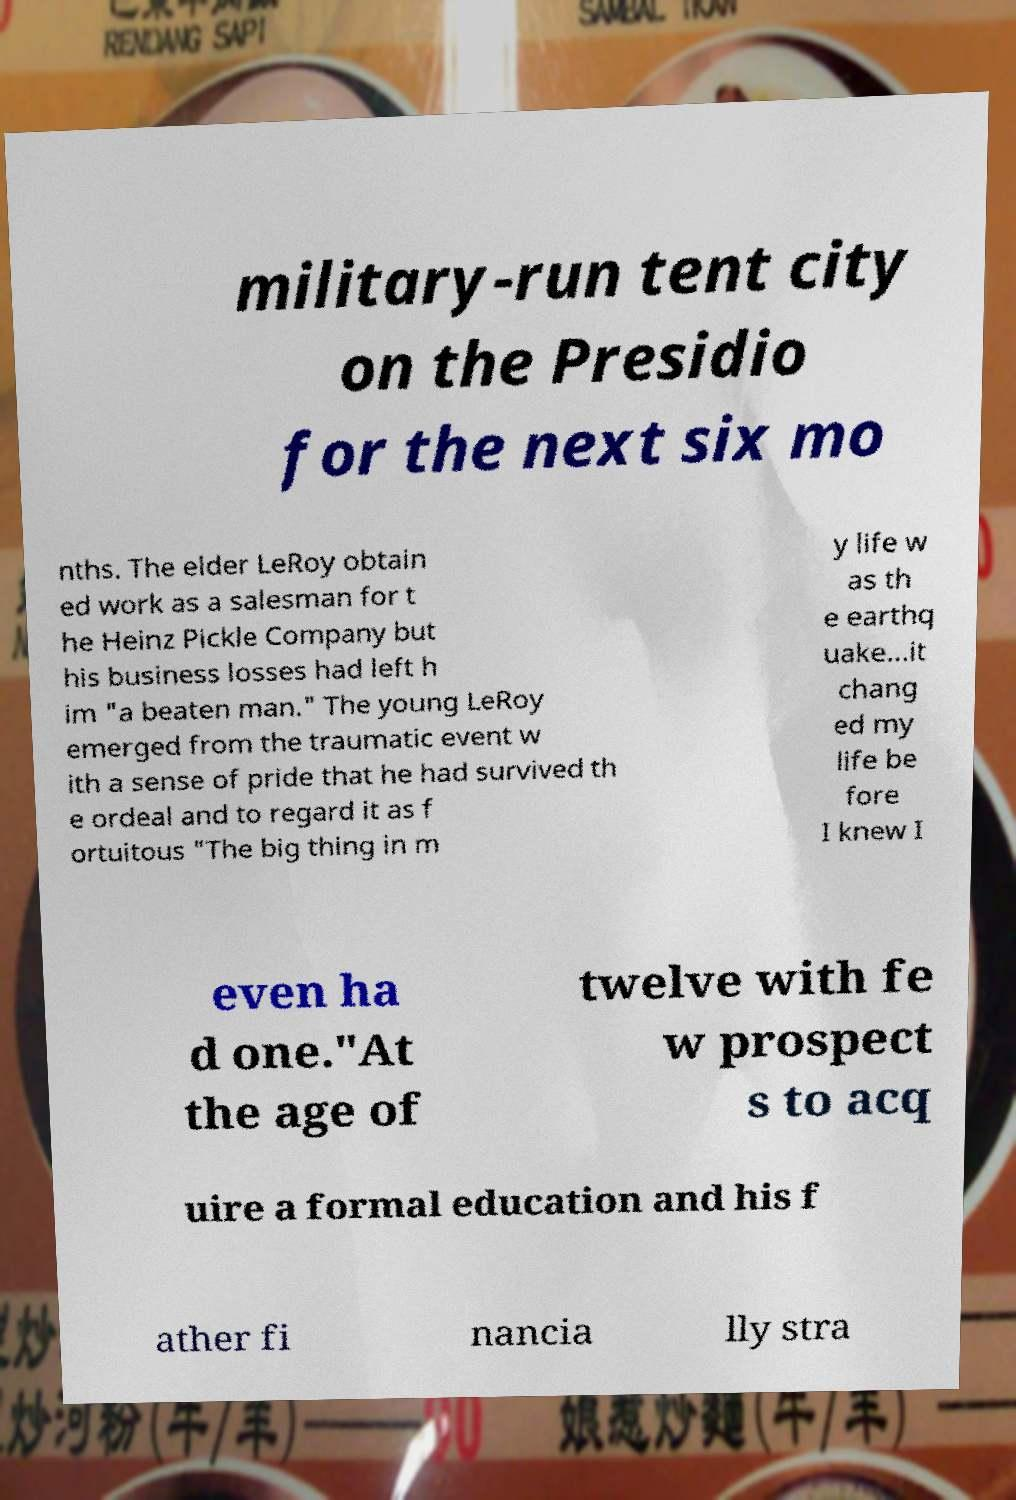Can you accurately transcribe the text from the provided image for me? military-run tent city on the Presidio for the next six mo nths. The elder LeRoy obtain ed work as a salesman for t he Heinz Pickle Company but his business losses had left h im "a beaten man." The young LeRoy emerged from the traumatic event w ith a sense of pride that he had survived th e ordeal and to regard it as f ortuitous "The big thing in m y life w as th e earthq uake...it chang ed my life be fore I knew I even ha d one."At the age of twelve with fe w prospect s to acq uire a formal education and his f ather fi nancia lly stra 